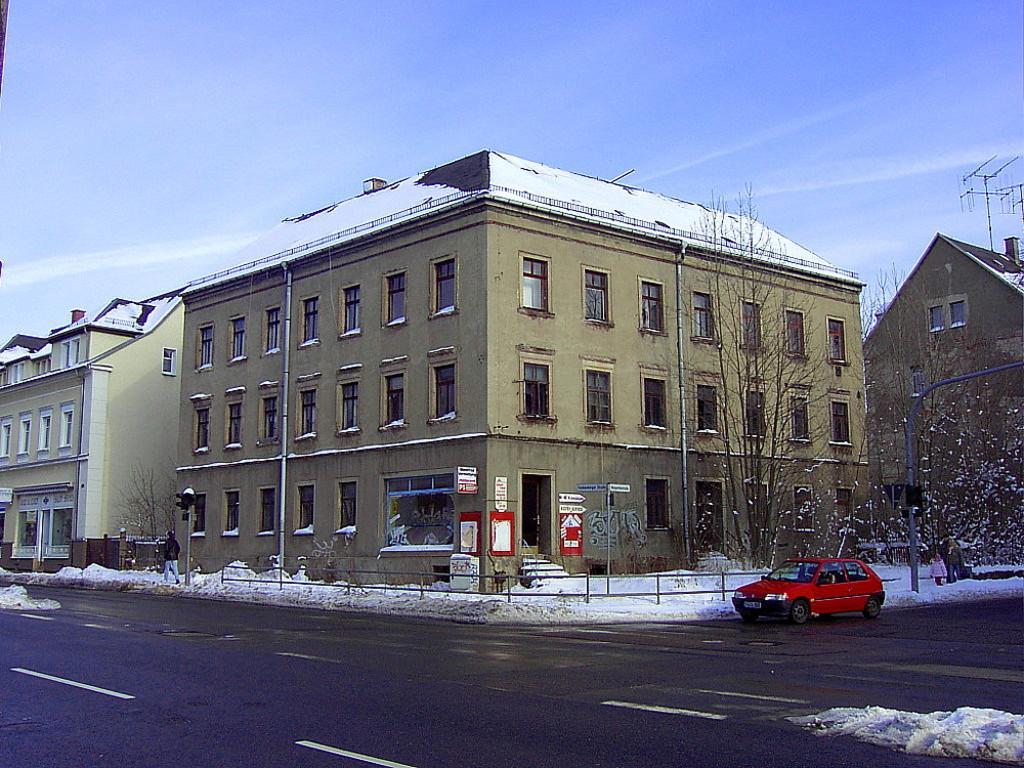Can you describe this image briefly? In this image in the middle there are buildings, trees, windows, staircase, posters, ice. At the bottom there is a car, railing, ice and road. On the left there is a person walking. At the top there are sky and clouds. 